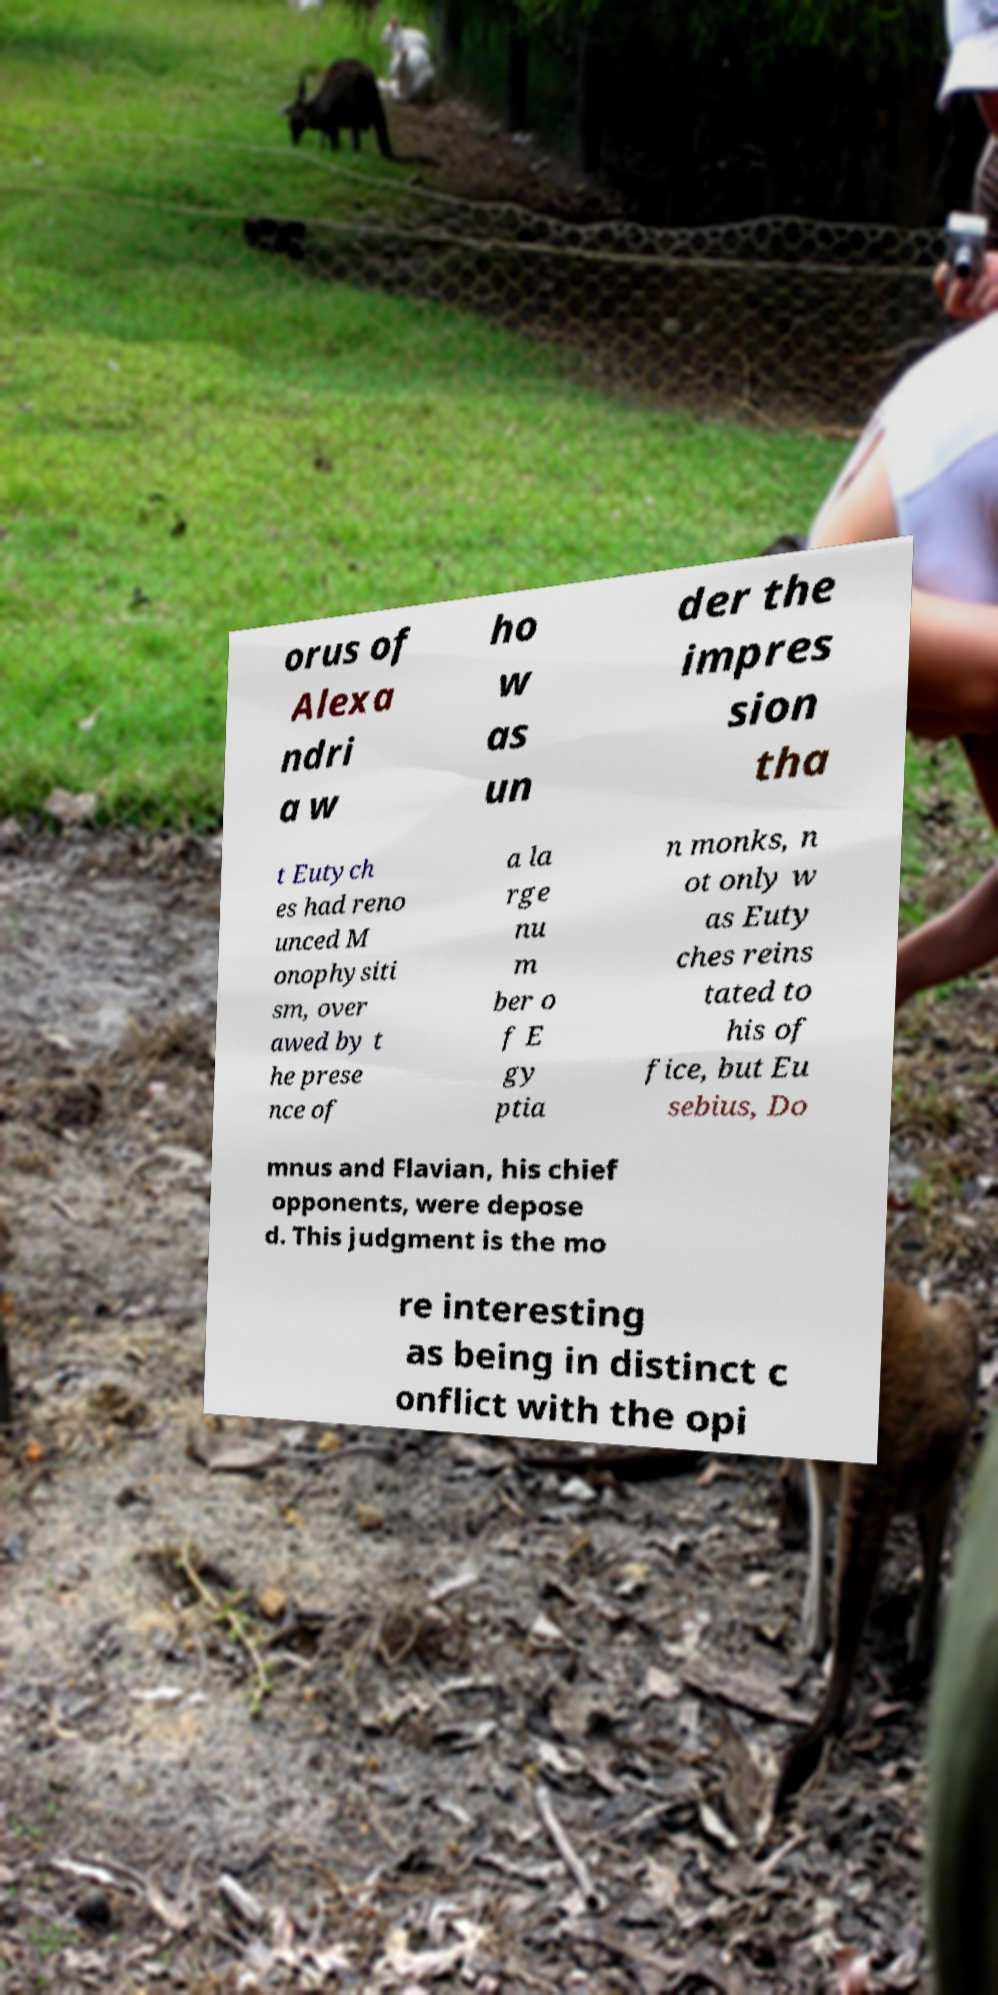Please identify and transcribe the text found in this image. orus of Alexa ndri a w ho w as un der the impres sion tha t Eutych es had reno unced M onophysiti sm, over awed by t he prese nce of a la rge nu m ber o f E gy ptia n monks, n ot only w as Euty ches reins tated to his of fice, but Eu sebius, Do mnus and Flavian, his chief opponents, were depose d. This judgment is the mo re interesting as being in distinct c onflict with the opi 